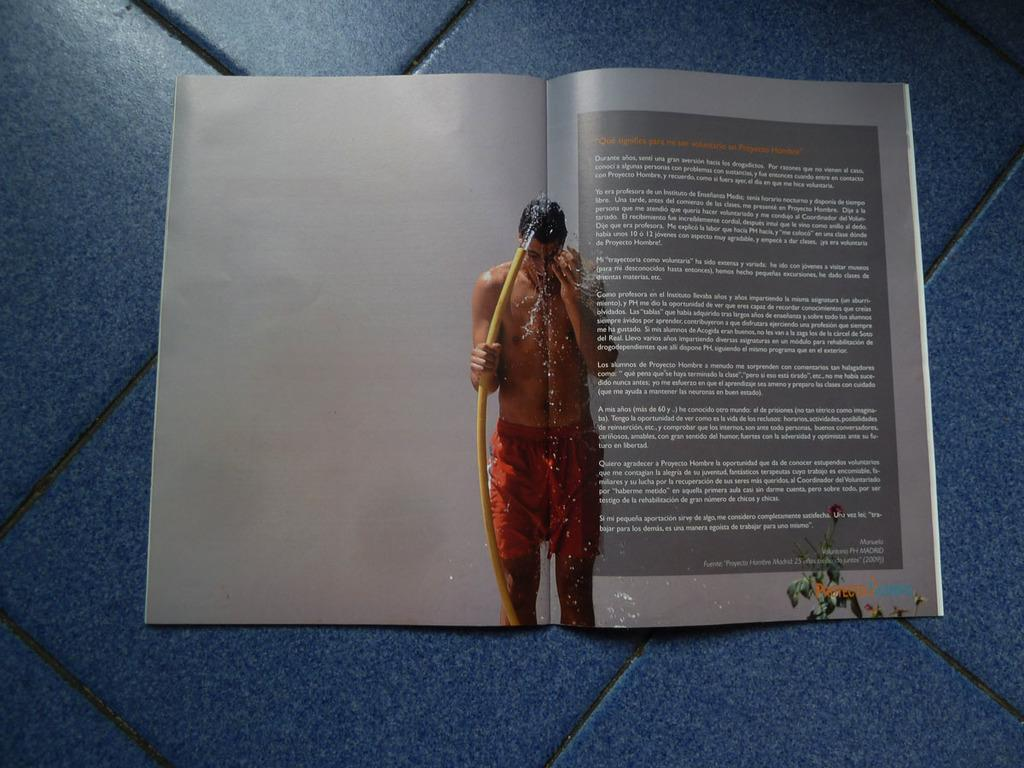What can be seen in the image related to reading material? There is a magazine in the image. Can you describe the content of the magazine? A person is visible in the magazine, and there is text written on the magazine. What is the setting of the image? The background of the image includes the floor. What time of day is the discussion taking place in the image? There is no discussion taking place in the image, and therefore no specific time of day can be determined. 